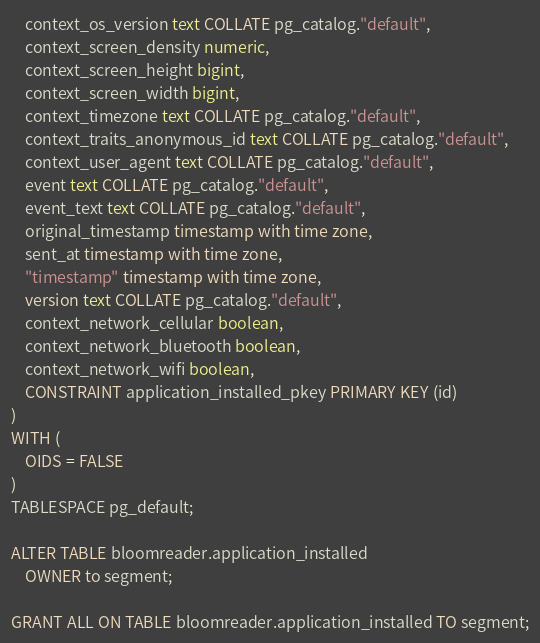<code> <loc_0><loc_0><loc_500><loc_500><_SQL_>    context_os_version text COLLATE pg_catalog."default",
    context_screen_density numeric,
    context_screen_height bigint,
    context_screen_width bigint,
    context_timezone text COLLATE pg_catalog."default",
    context_traits_anonymous_id text COLLATE pg_catalog."default",
    context_user_agent text COLLATE pg_catalog."default",
    event text COLLATE pg_catalog."default",
    event_text text COLLATE pg_catalog."default",
    original_timestamp timestamp with time zone,
    sent_at timestamp with time zone,
    "timestamp" timestamp with time zone,
    version text COLLATE pg_catalog."default",
    context_network_cellular boolean,
    context_network_bluetooth boolean,
    context_network_wifi boolean,
    CONSTRAINT application_installed_pkey PRIMARY KEY (id)
)
WITH (
    OIDS = FALSE
)
TABLESPACE pg_default;

ALTER TABLE bloomreader.application_installed
    OWNER to segment;

GRANT ALL ON TABLE bloomreader.application_installed TO segment;</code> 